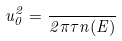Convert formula to latex. <formula><loc_0><loc_0><loc_500><loc_500>u _ { 0 } ^ { 2 } = \frac { } { 2 \pi \tau n ( E ) }</formula> 